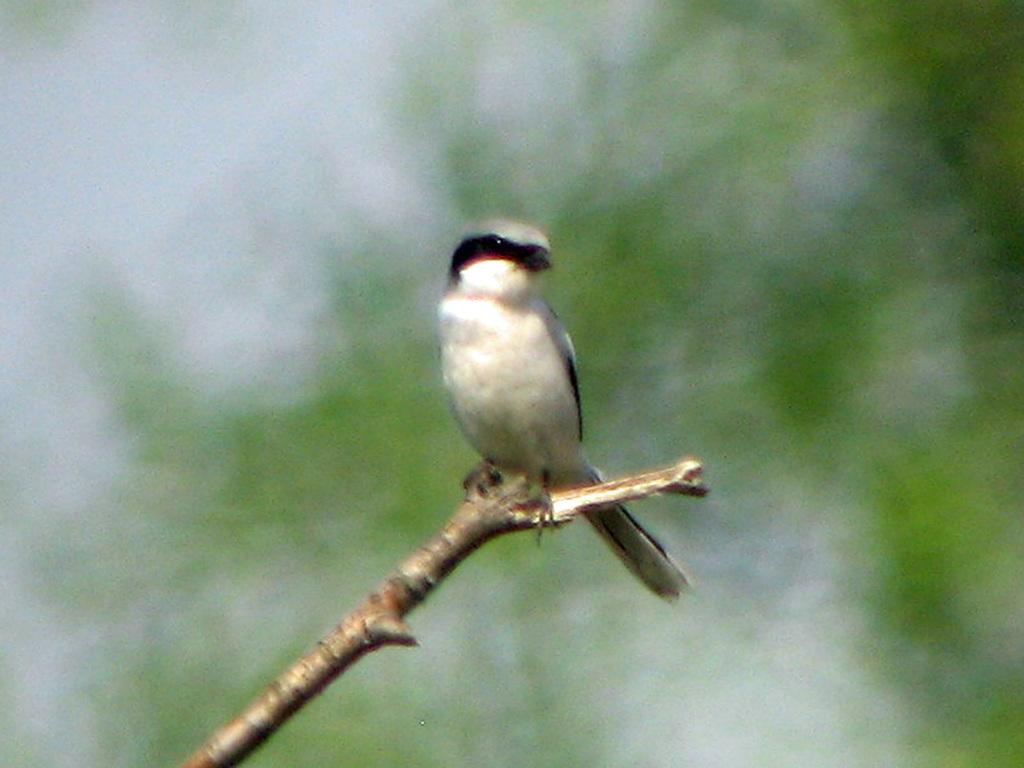What is the main subject in the center of the image? There is a wood in the center of the image. Is there any living creature on the wood? Yes, there is a bird on the wood. What can be said about the bird's appearance? The bird is in black and white color. What type of harmony is the bird playing on the wood? There is no indication in the image that the bird is playing any type of harmony, as birds do not play musical instruments. 